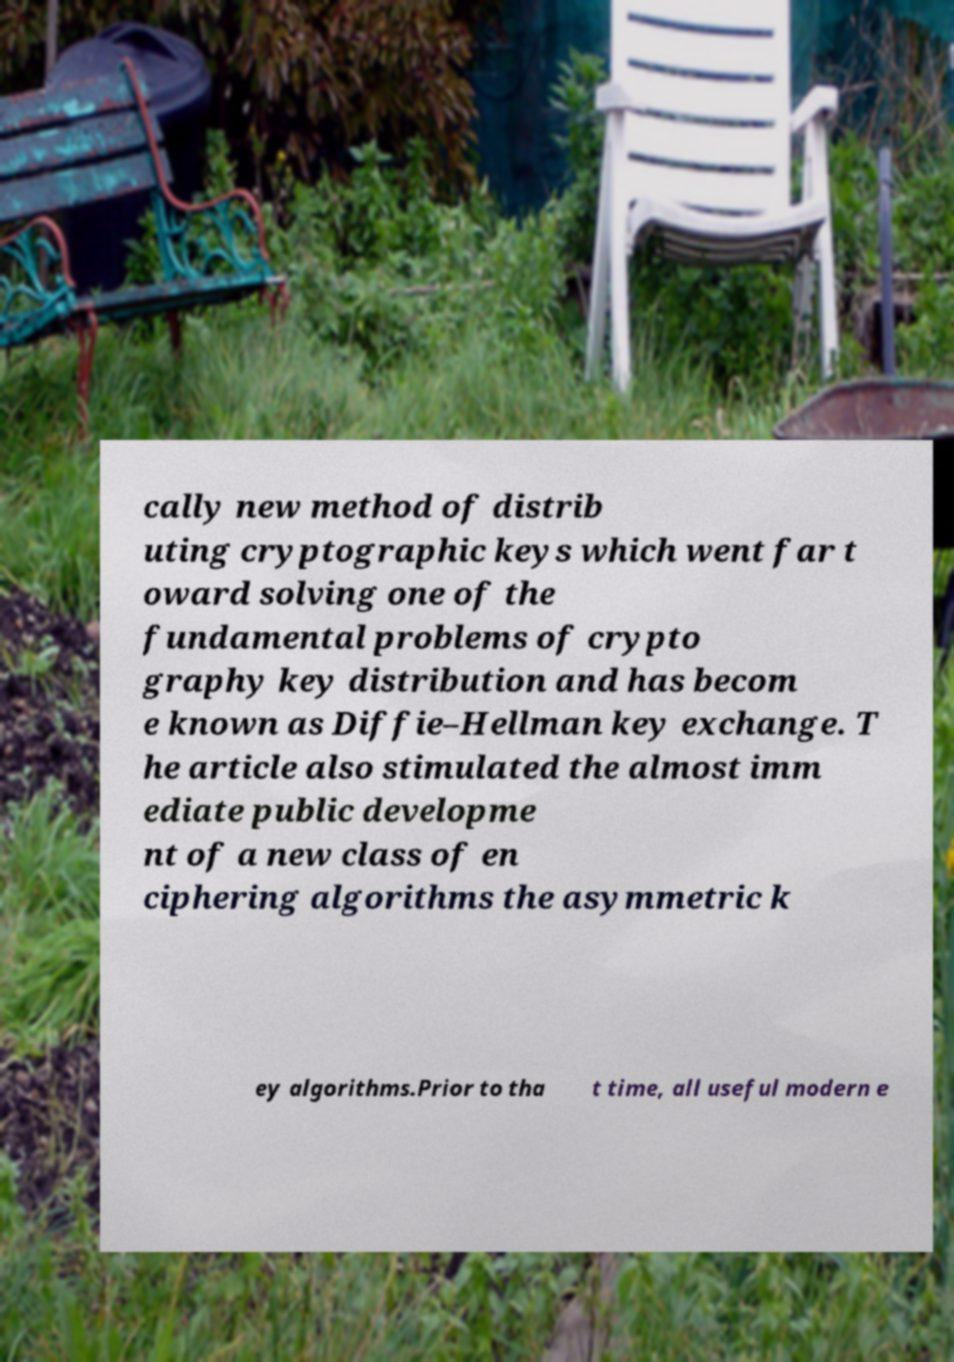Could you assist in decoding the text presented in this image and type it out clearly? cally new method of distrib uting cryptographic keys which went far t oward solving one of the fundamental problems of crypto graphy key distribution and has becom e known as Diffie–Hellman key exchange. T he article also stimulated the almost imm ediate public developme nt of a new class of en ciphering algorithms the asymmetric k ey algorithms.Prior to tha t time, all useful modern e 